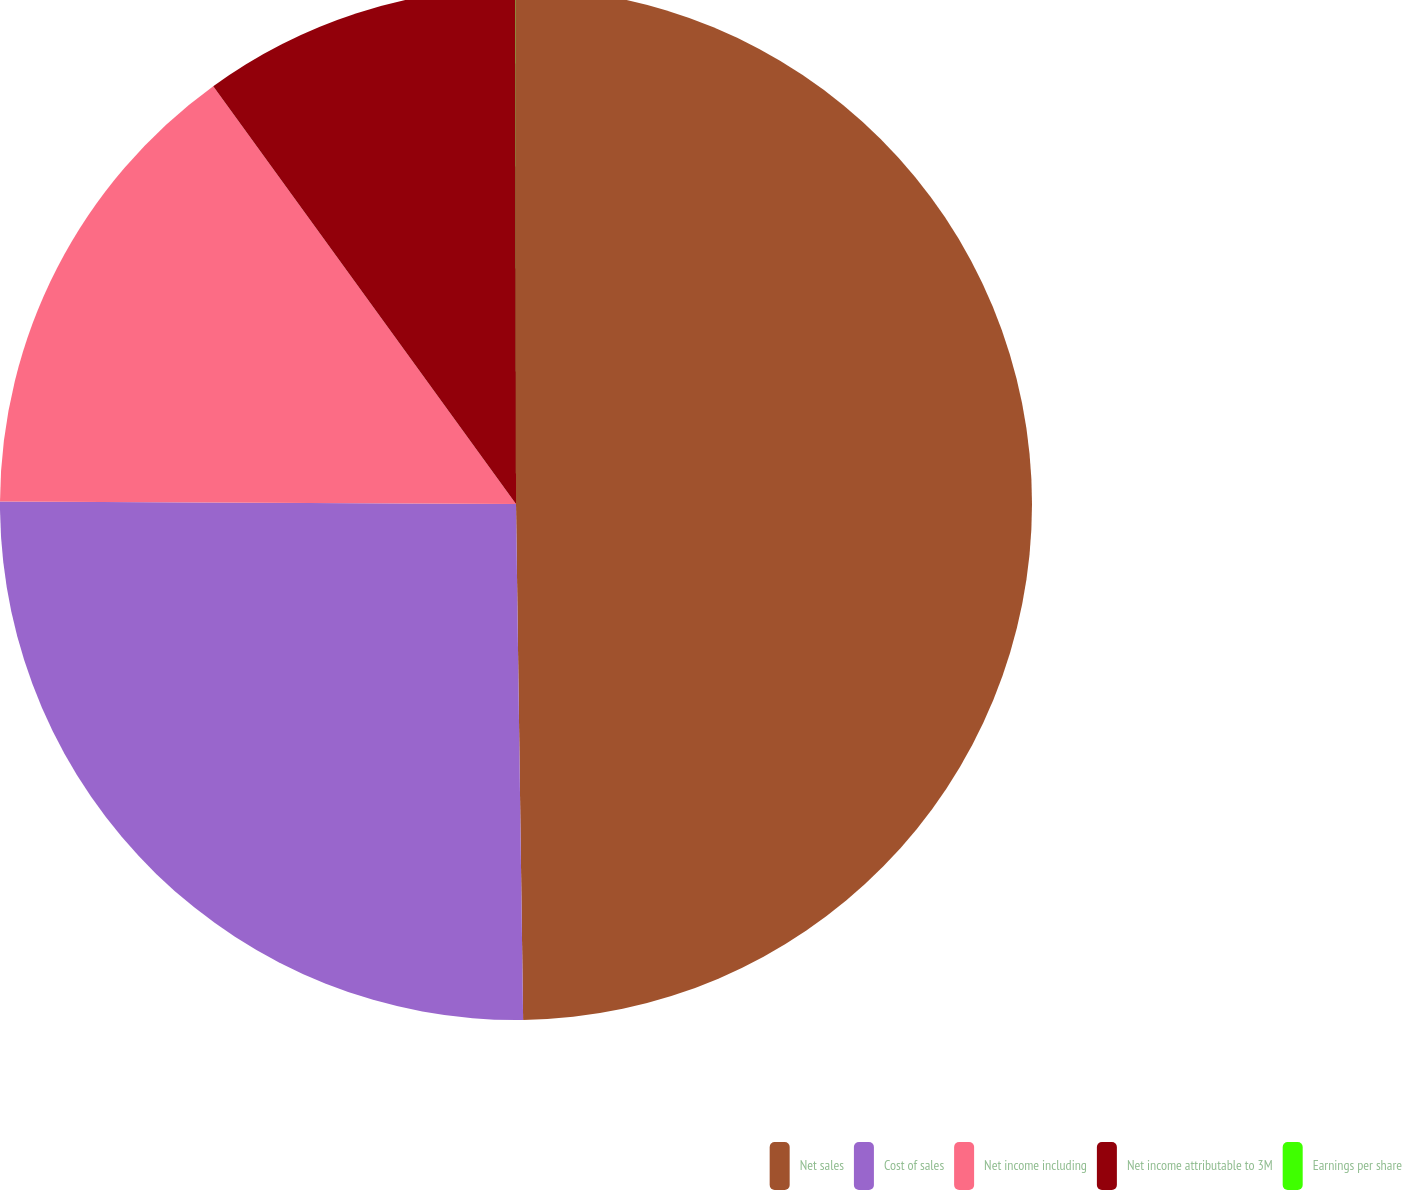Convert chart to OTSL. <chart><loc_0><loc_0><loc_500><loc_500><pie_chart><fcel>Net sales<fcel>Cost of sales<fcel>Net income including<fcel>Net income attributable to 3M<fcel>Earnings per share<nl><fcel>49.78%<fcel>25.3%<fcel>14.94%<fcel>9.97%<fcel>0.01%<nl></chart> 